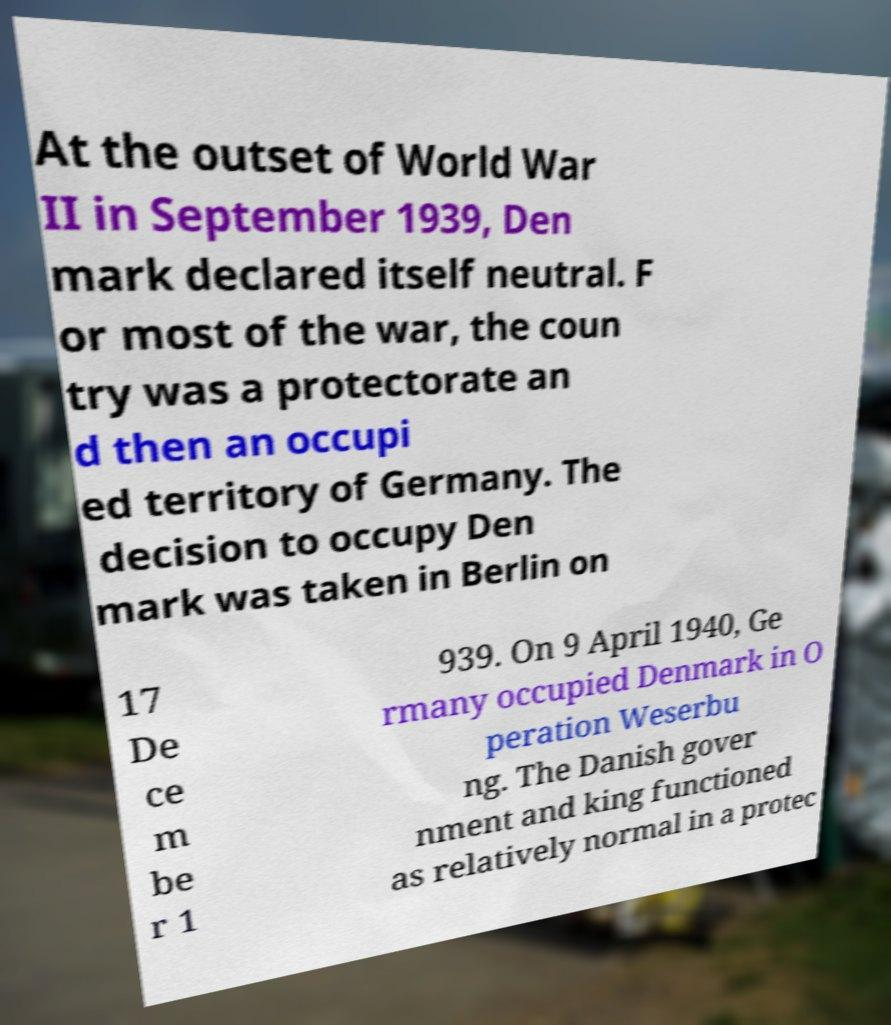Please read and relay the text visible in this image. What does it say? At the outset of World War II in September 1939, Den mark declared itself neutral. F or most of the war, the coun try was a protectorate an d then an occupi ed territory of Germany. The decision to occupy Den mark was taken in Berlin on 17 De ce m be r 1 939. On 9 April 1940, Ge rmany occupied Denmark in O peration Weserbu ng. The Danish gover nment and king functioned as relatively normal in a protec 